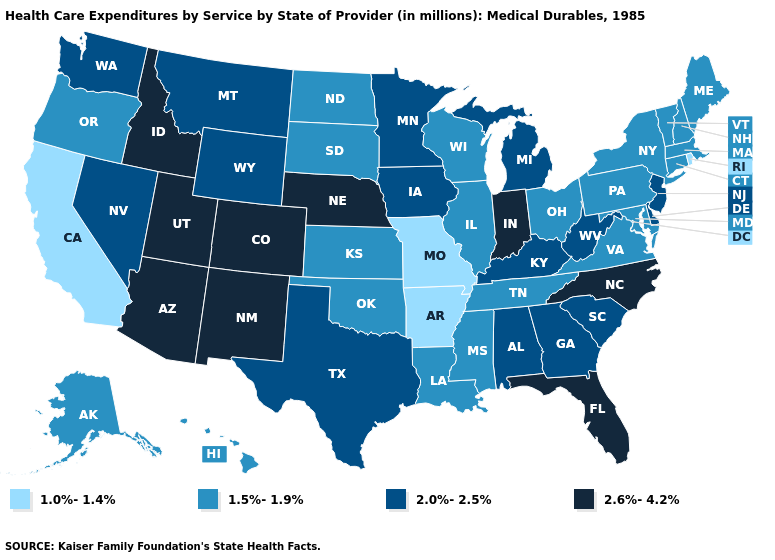Name the states that have a value in the range 1.5%-1.9%?
Be succinct. Alaska, Connecticut, Hawaii, Illinois, Kansas, Louisiana, Maine, Maryland, Massachusetts, Mississippi, New Hampshire, New York, North Dakota, Ohio, Oklahoma, Oregon, Pennsylvania, South Dakota, Tennessee, Vermont, Virginia, Wisconsin. What is the highest value in the USA?
Write a very short answer. 2.6%-4.2%. Which states hav the highest value in the Northeast?
Answer briefly. New Jersey. Name the states that have a value in the range 1.0%-1.4%?
Keep it brief. Arkansas, California, Missouri, Rhode Island. What is the value of Arizona?
Concise answer only. 2.6%-4.2%. What is the value of Nevada?
Answer briefly. 2.0%-2.5%. Does Montana have the lowest value in the West?
Answer briefly. No. Which states have the lowest value in the MidWest?
Quick response, please. Missouri. Name the states that have a value in the range 1.0%-1.4%?
Short answer required. Arkansas, California, Missouri, Rhode Island. What is the value of Delaware?
Write a very short answer. 2.0%-2.5%. Does Oklahoma have a higher value than Rhode Island?
Write a very short answer. Yes. Does the map have missing data?
Keep it brief. No. Name the states that have a value in the range 2.6%-4.2%?
Answer briefly. Arizona, Colorado, Florida, Idaho, Indiana, Nebraska, New Mexico, North Carolina, Utah. Which states have the lowest value in the USA?
Write a very short answer. Arkansas, California, Missouri, Rhode Island. Name the states that have a value in the range 1.0%-1.4%?
Answer briefly. Arkansas, California, Missouri, Rhode Island. 